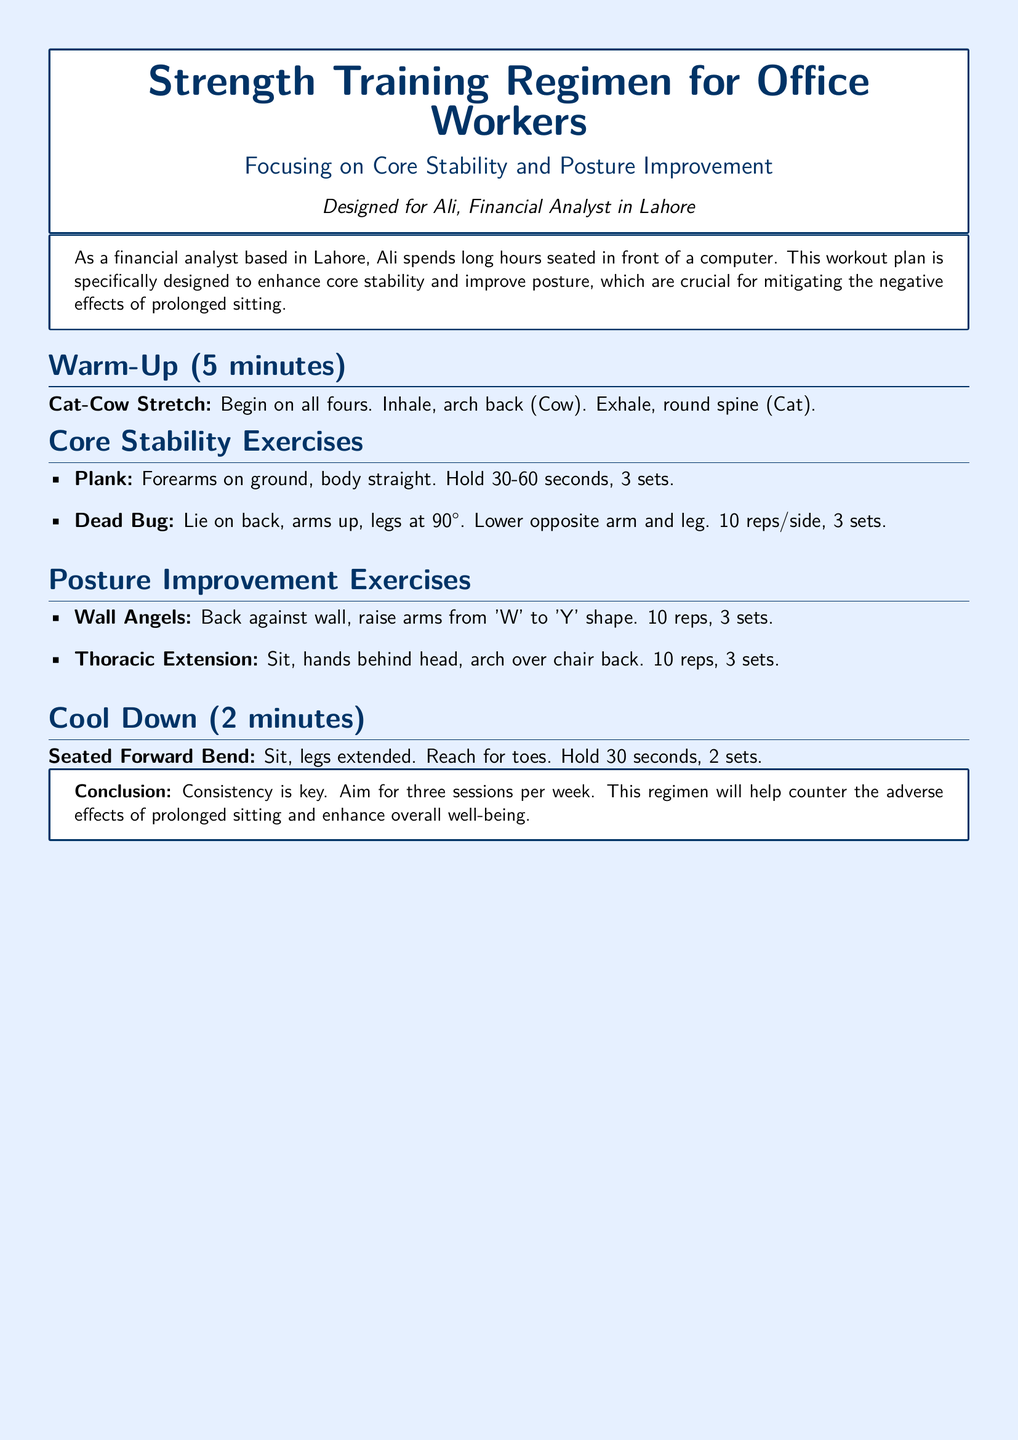What is the title of the document? The title is prominently displayed and states the focus of the regimen.
Answer: Strength Training Regimen for Office Workers Who is the workout plan designed for? The document specifies the individual the plan is intended for, reflecting a targeted approach.
Answer: Ali How many sets of the Plank are recommended? The document lists the number of sets for each exercise under core stability exercises.
Answer: 3 sets What exercise involves a 'W' to 'Y' arm movement? This is mentioned as a specific posture improvement exercise in the document.
Answer: Wall Angels What is the total duration of the warm-up? The document clearly states the time allocated for warming up at the beginning of the exercise regimen.
Answer: 5 minutes How many sessions per week does the document recommend? The conclusion clearly indicates the frequency of sessions recommended for effectiveness.
Answer: Three sessions What core stability exercise requires lying on the back? The document states this exercise in the core stability section.
Answer: Dead Bug What is the duration for holding the Seated Forward Bend? The document specifies the time for this cool-down exercise.
Answer: 30 seconds 